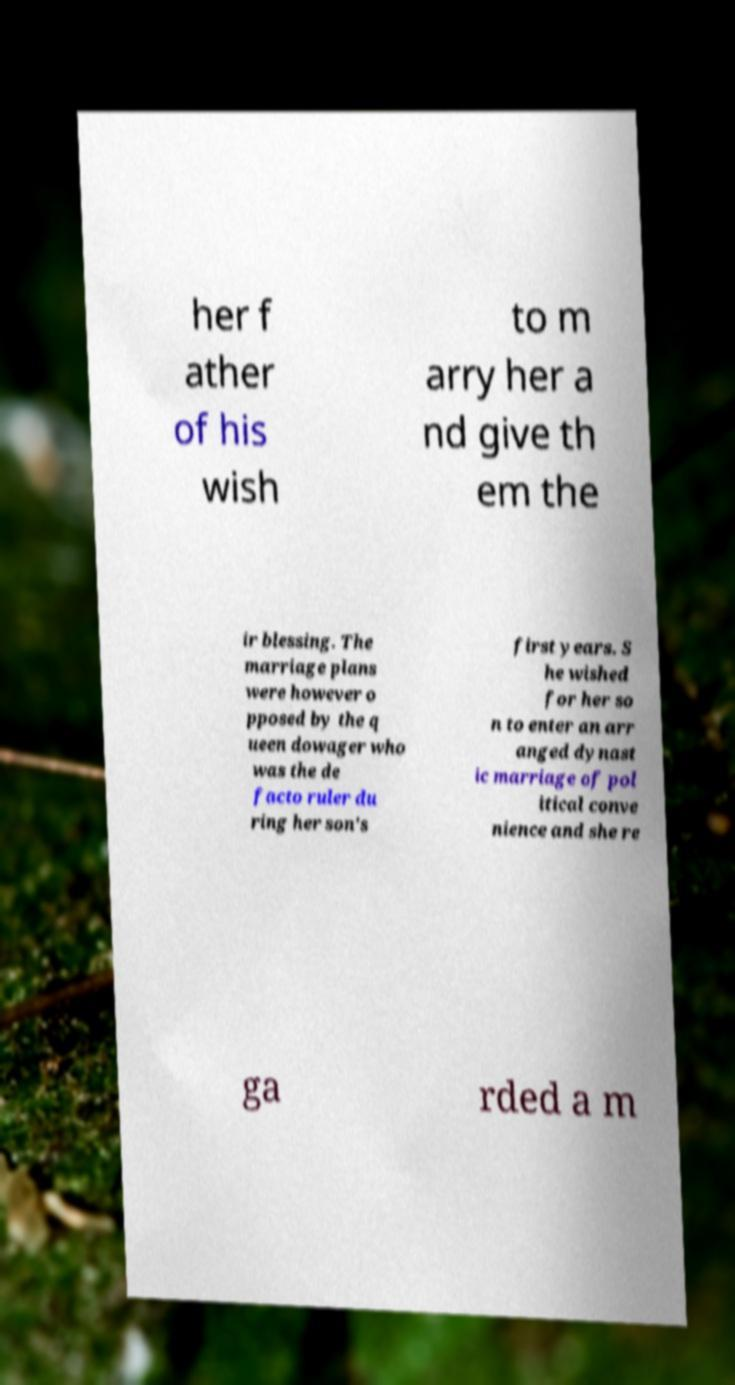What messages or text are displayed in this image? I need them in a readable, typed format. her f ather of his wish to m arry her a nd give th em the ir blessing. The marriage plans were however o pposed by the q ueen dowager who was the de facto ruler du ring her son's first years. S he wished for her so n to enter an arr anged dynast ic marriage of pol itical conve nience and she re ga rded a m 